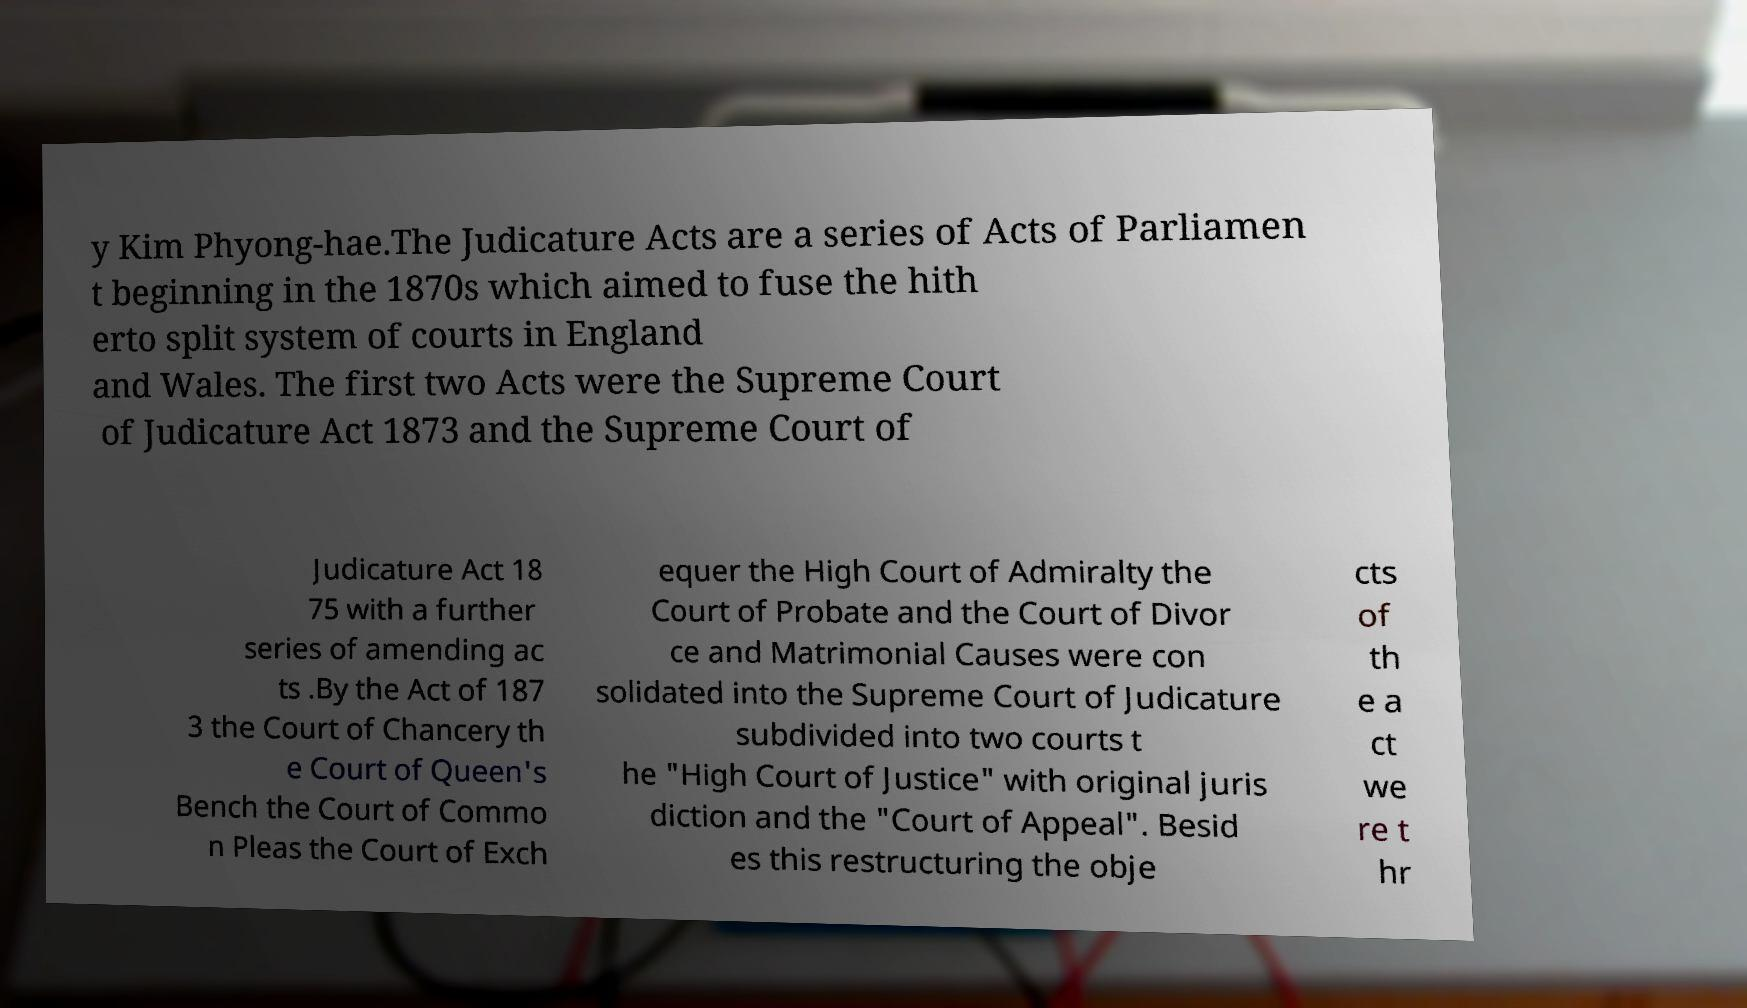There's text embedded in this image that I need extracted. Can you transcribe it verbatim? y Kim Phyong-hae.The Judicature Acts are a series of Acts of Parliamen t beginning in the 1870s which aimed to fuse the hith erto split system of courts in England and Wales. The first two Acts were the Supreme Court of Judicature Act 1873 and the Supreme Court of Judicature Act 18 75 with a further series of amending ac ts .By the Act of 187 3 the Court of Chancery th e Court of Queen's Bench the Court of Commo n Pleas the Court of Exch equer the High Court of Admiralty the Court of Probate and the Court of Divor ce and Matrimonial Causes were con solidated into the Supreme Court of Judicature subdivided into two courts t he "High Court of Justice" with original juris diction and the "Court of Appeal". Besid es this restructuring the obje cts of th e a ct we re t hr 